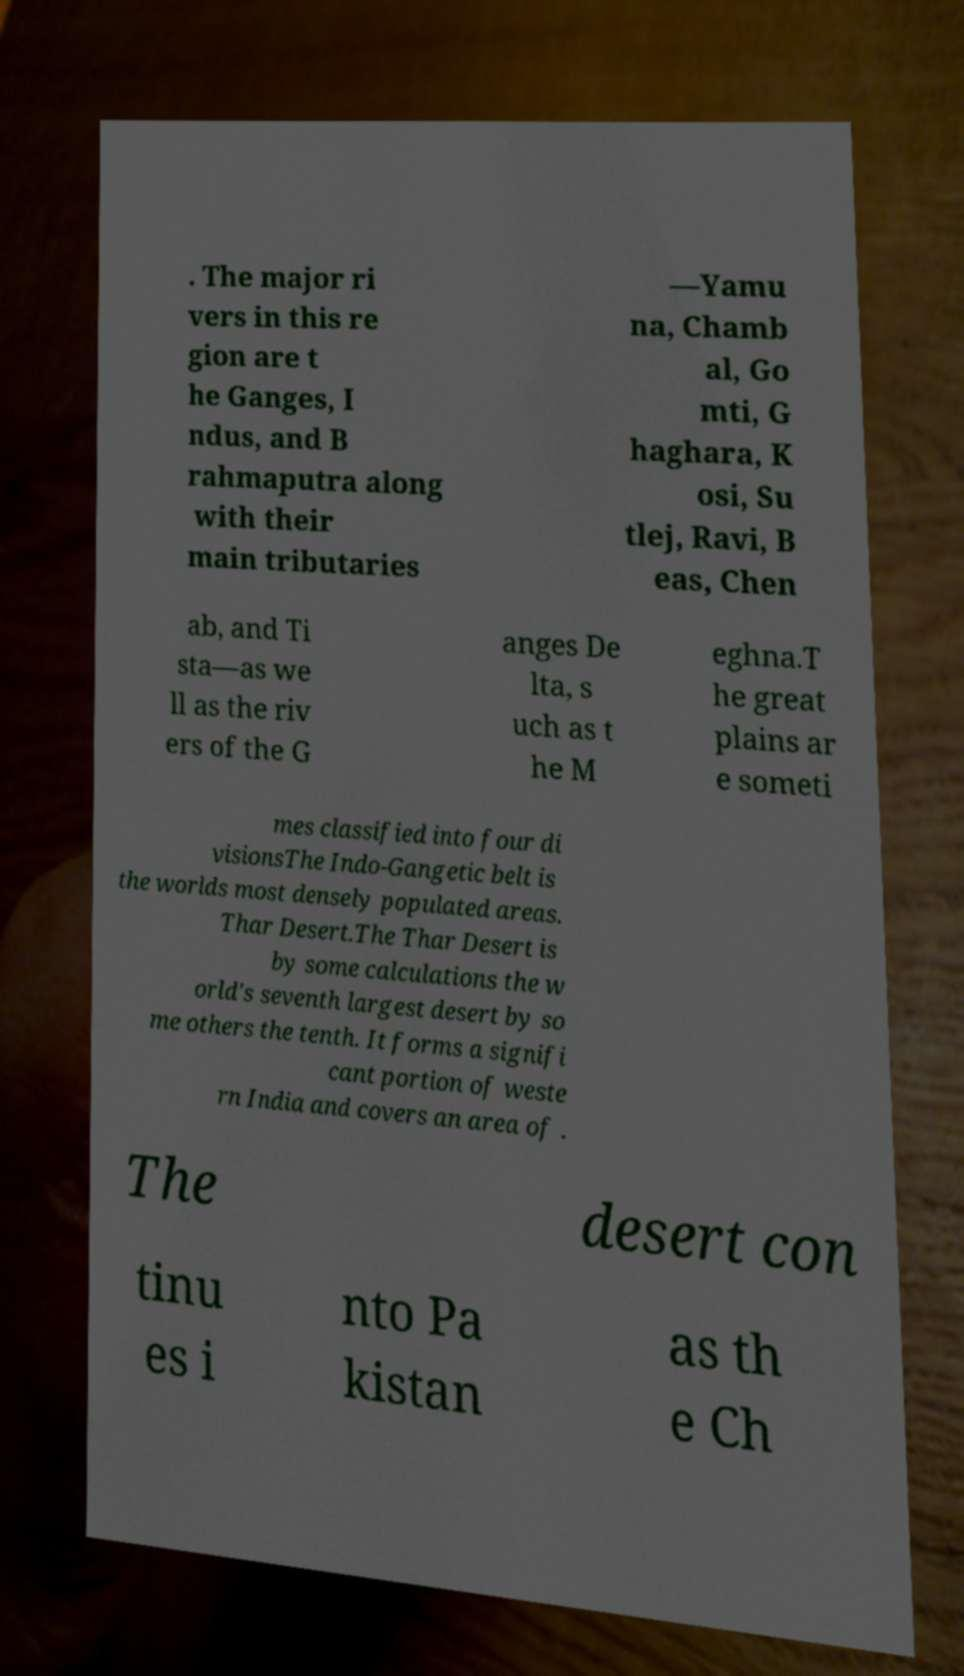Could you extract and type out the text from this image? . The major ri vers in this re gion are t he Ganges, I ndus, and B rahmaputra along with their main tributaries —Yamu na, Chamb al, Go mti, G haghara, K osi, Su tlej, Ravi, B eas, Chen ab, and Ti sta—as we ll as the riv ers of the G anges De lta, s uch as t he M eghna.T he great plains ar e someti mes classified into four di visionsThe Indo-Gangetic belt is the worlds most densely populated areas. Thar Desert.The Thar Desert is by some calculations the w orld's seventh largest desert by so me others the tenth. It forms a signifi cant portion of weste rn India and covers an area of . The desert con tinu es i nto Pa kistan as th e Ch 